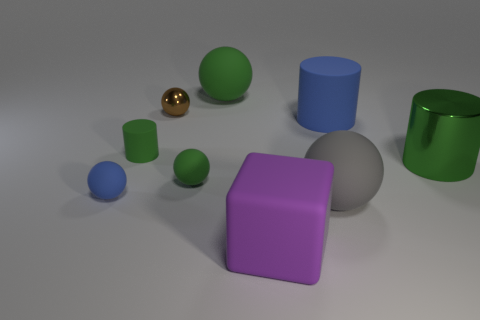Subtract 3 balls. How many balls are left? 2 Subtract all brown spheres. How many spheres are left? 4 Subtract all tiny green balls. How many balls are left? 4 Subtract all red balls. Subtract all brown blocks. How many balls are left? 5 Add 1 big blue metal cylinders. How many objects exist? 10 Subtract all balls. How many objects are left? 4 Subtract all tiny blue metal blocks. Subtract all tiny metallic balls. How many objects are left? 8 Add 9 big green cylinders. How many big green cylinders are left? 10 Add 1 green cylinders. How many green cylinders exist? 3 Subtract 0 yellow cylinders. How many objects are left? 9 